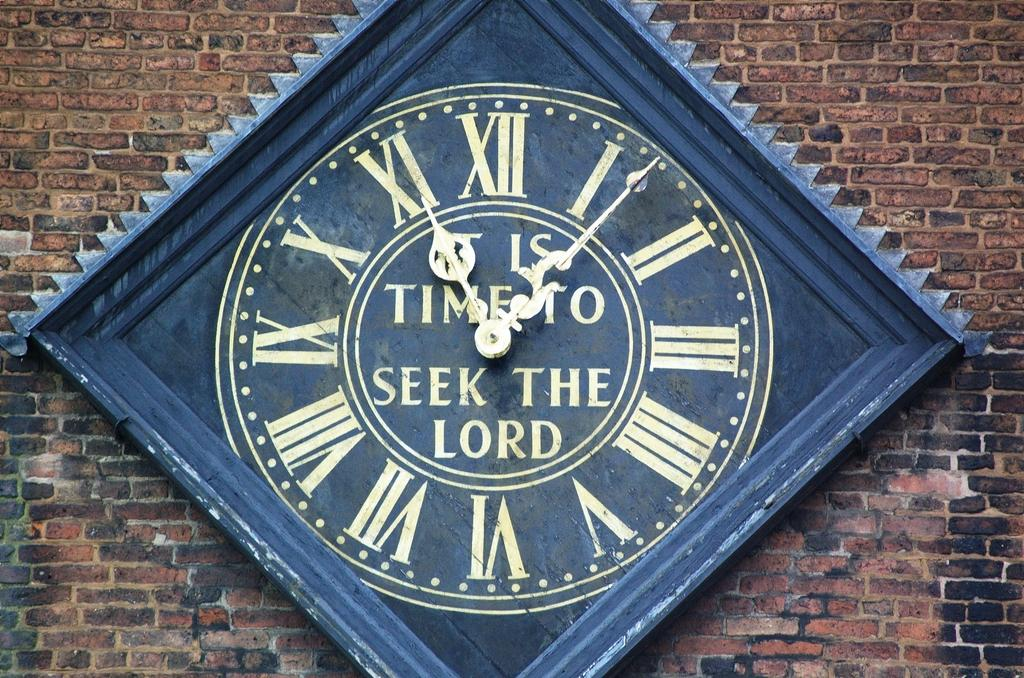<image>
Offer a succinct explanation of the picture presented. A clock with roman numerals says it is time to seek the lord. 